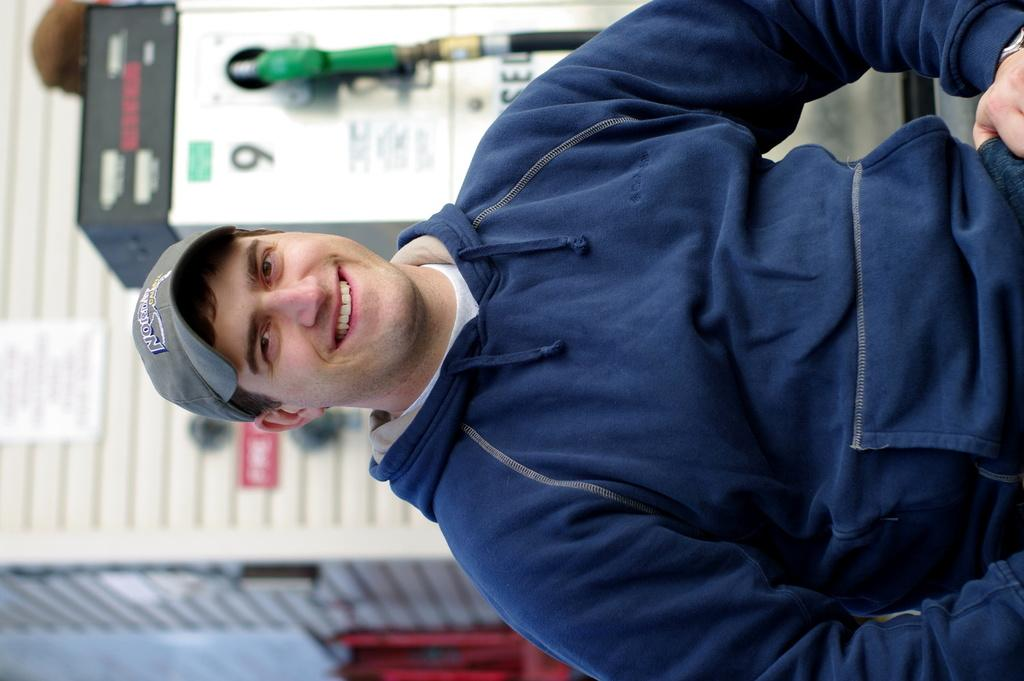Who is present in the image? There is a man in the image. What is the man doing in the image? The man is smiling in the image. What is the man wearing on his head? The man is wearing a cap in the image. What can be seen in the background of the image? The background of the image appears to be a filling station. How would you describe the quality of the image? The image is blurred. What type of leather is visible on the man's shoes in the image? There is no mention of shoes or leather in the image, so it cannot be determined from the image. 